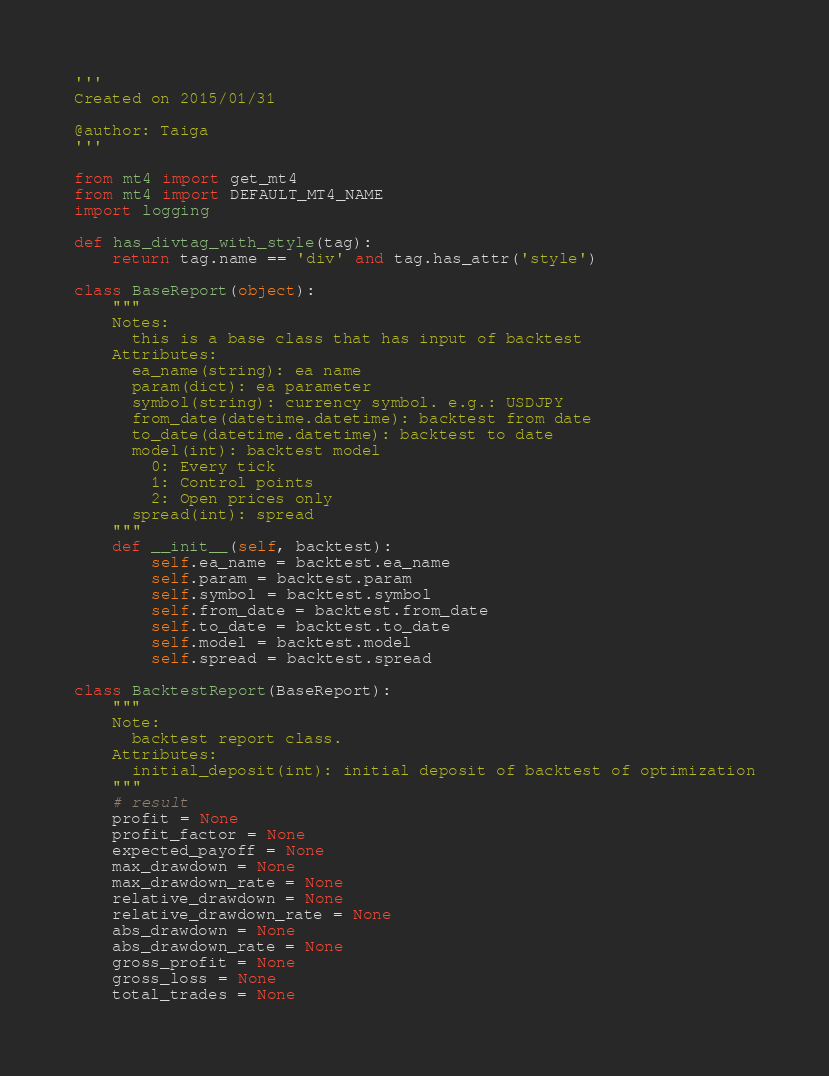Convert code to text. <code><loc_0><loc_0><loc_500><loc_500><_Python_>'''
Created on 2015/01/31

@author: Taiga
'''

from mt4 import get_mt4
from mt4 import DEFAULT_MT4_NAME
import logging

def has_divtag_with_style(tag):
    return tag.name == 'div' and tag.has_attr('style')

class BaseReport(object):
    """
    Notes:
      this is a base class that has input of backtest
    Attributes:
      ea_name(string): ea name
      param(dict): ea parameter
      symbol(string): currency symbol. e.g.: USDJPY
      from_date(datetime.datetime): backtest from date
      to_date(datetime.datetime): backtest to date
      model(int): backtest model 
        0: Every tick
        1: Control points
        2: Open prices only
      spread(int): spread
    """
    def __init__(self, backtest):
        self.ea_name = backtest.ea_name
        self.param = backtest.param
        self.symbol = backtest.symbol
        self.from_date = backtest.from_date
        self.to_date = backtest.to_date
        self.model = backtest.model
        self.spread = backtest.spread

class BacktestReport(BaseReport):
    """
    Note:
      backtest report class.
    Attributes:
      initial_deposit(int): initial deposit of backtest of optimization
    """
    # result
    profit = None
    profit_factor = None
    expected_payoff = None
    max_drawdown = None
    max_drawdown_rate = None
    relative_drawdown = None
    relative_drawdown_rate = None
    abs_drawdown = None
    abs_drawdown_rate = None
    gross_profit = None
    gross_loss = None
    total_trades = None</code> 